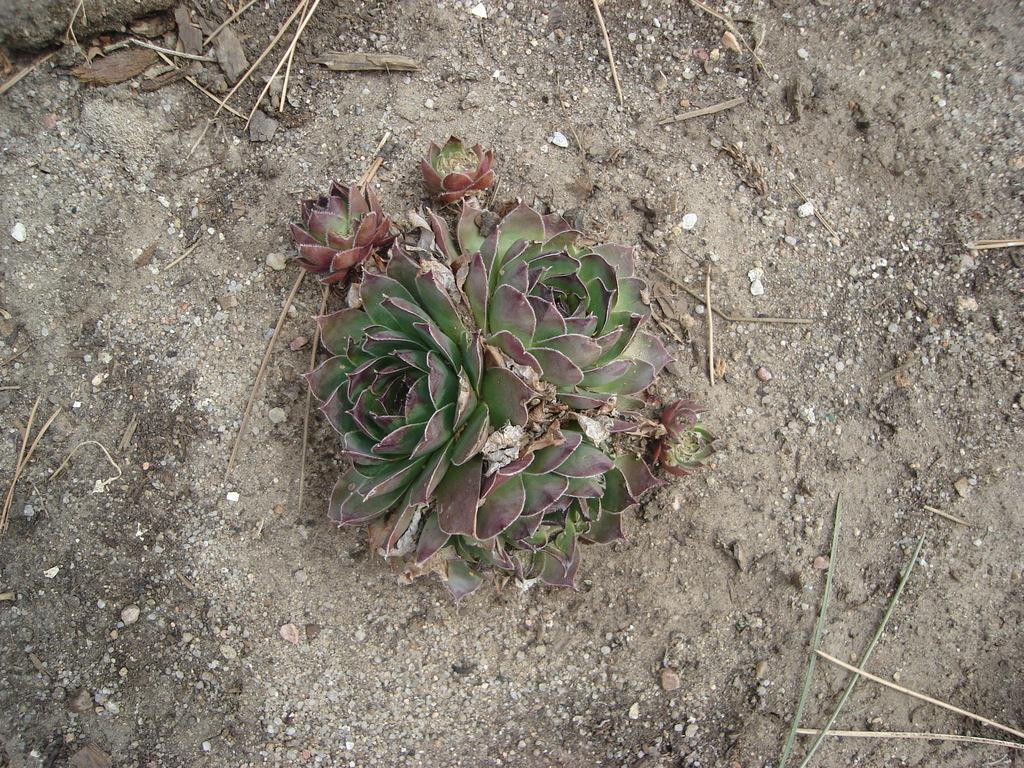What is present on the ground in the image? There is a plant in the image. Can you describe the location of the plant in the image? The plant is on the ground. What type of surface is visible in the image? There is ground visible in the image. What month is it in the image? The month cannot be determined from the image, as there is no information about the time of year or any seasonal indicators present. 